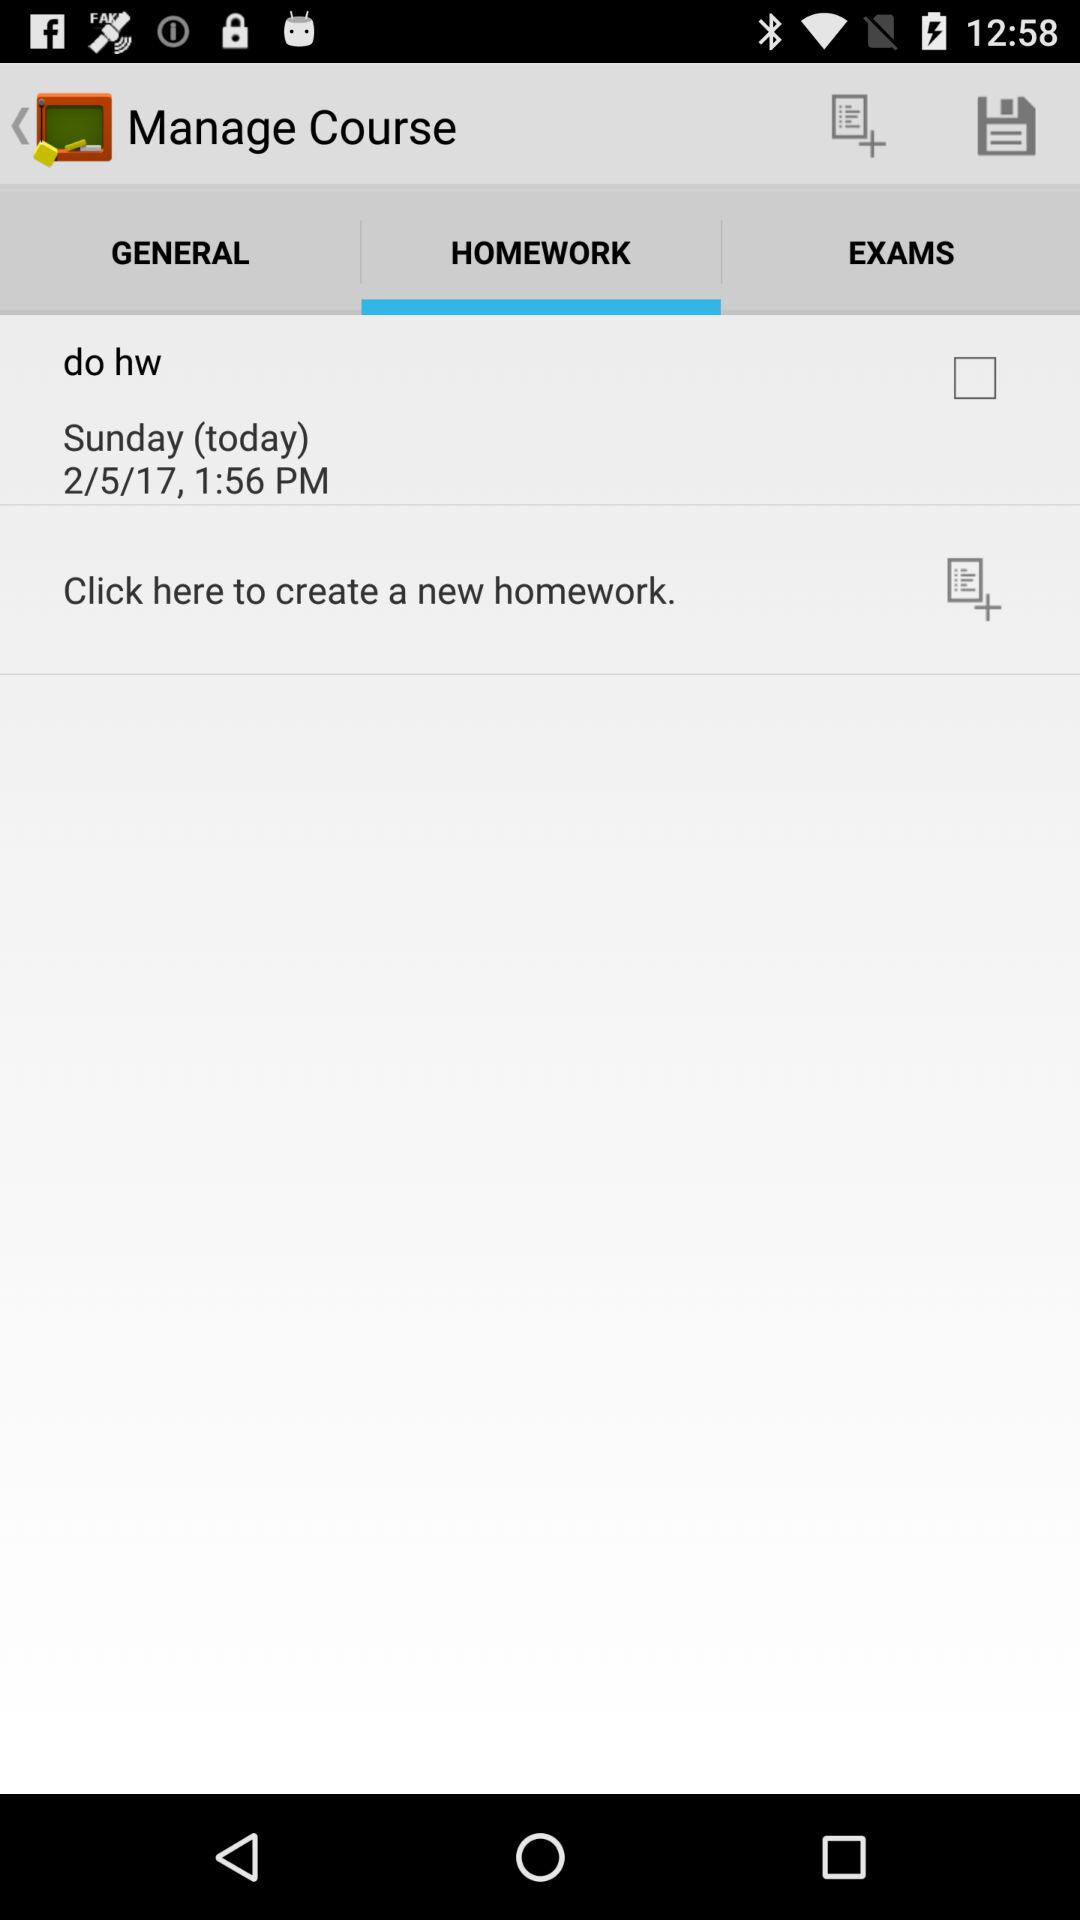What is the mentioned time? The mentioned time is 1:56 p.m. 